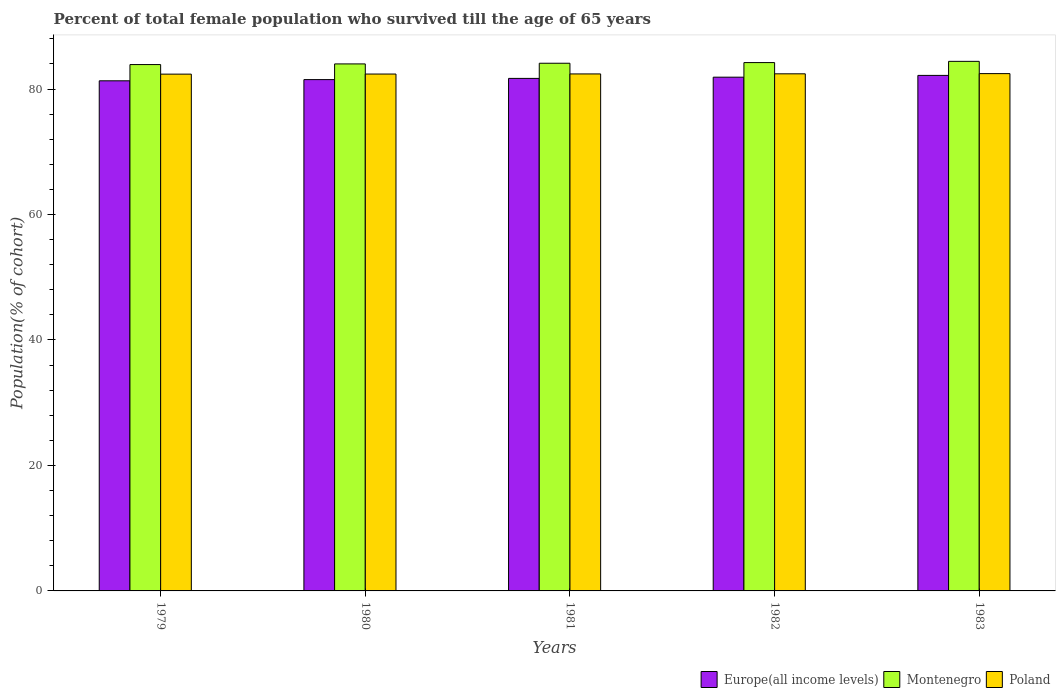How many different coloured bars are there?
Your response must be concise. 3. Are the number of bars per tick equal to the number of legend labels?
Your answer should be compact. Yes. How many bars are there on the 4th tick from the left?
Keep it short and to the point. 3. How many bars are there on the 3rd tick from the right?
Give a very brief answer. 3. What is the percentage of total female population who survived till the age of 65 years in Montenegro in 1982?
Offer a very short reply. 84.22. Across all years, what is the maximum percentage of total female population who survived till the age of 65 years in Europe(all income levels)?
Provide a short and direct response. 82.18. Across all years, what is the minimum percentage of total female population who survived till the age of 65 years in Montenegro?
Provide a succinct answer. 83.9. In which year was the percentage of total female population who survived till the age of 65 years in Europe(all income levels) maximum?
Provide a short and direct response. 1983. In which year was the percentage of total female population who survived till the age of 65 years in Europe(all income levels) minimum?
Ensure brevity in your answer.  1979. What is the total percentage of total female population who survived till the age of 65 years in Europe(all income levels) in the graph?
Give a very brief answer. 408.58. What is the difference between the percentage of total female population who survived till the age of 65 years in Europe(all income levels) in 1980 and that in 1983?
Give a very brief answer. -0.67. What is the difference between the percentage of total female population who survived till the age of 65 years in Europe(all income levels) in 1981 and the percentage of total female population who survived till the age of 65 years in Montenegro in 1979?
Your response must be concise. -2.21. What is the average percentage of total female population who survived till the age of 65 years in Europe(all income levels) per year?
Give a very brief answer. 81.72. In the year 1982, what is the difference between the percentage of total female population who survived till the age of 65 years in Montenegro and percentage of total female population who survived till the age of 65 years in Poland?
Offer a terse response. 1.79. What is the ratio of the percentage of total female population who survived till the age of 65 years in Europe(all income levels) in 1981 to that in 1982?
Offer a very short reply. 1. Is the percentage of total female population who survived till the age of 65 years in Poland in 1981 less than that in 1983?
Provide a succinct answer. Yes. What is the difference between the highest and the second highest percentage of total female population who survived till the age of 65 years in Montenegro?
Your answer should be compact. 0.2. What is the difference between the highest and the lowest percentage of total female population who survived till the age of 65 years in Europe(all income levels)?
Offer a terse response. 0.86. Is it the case that in every year, the sum of the percentage of total female population who survived till the age of 65 years in Montenegro and percentage of total female population who survived till the age of 65 years in Poland is greater than the percentage of total female population who survived till the age of 65 years in Europe(all income levels)?
Keep it short and to the point. Yes. How many bars are there?
Keep it short and to the point. 15. What is the difference between two consecutive major ticks on the Y-axis?
Ensure brevity in your answer.  20. Does the graph contain any zero values?
Offer a very short reply. No. Does the graph contain grids?
Your answer should be compact. No. How many legend labels are there?
Your answer should be compact. 3. What is the title of the graph?
Give a very brief answer. Percent of total female population who survived till the age of 65 years. Does "Poland" appear as one of the legend labels in the graph?
Offer a terse response. Yes. What is the label or title of the X-axis?
Offer a terse response. Years. What is the label or title of the Y-axis?
Provide a short and direct response. Population(% of cohort). What is the Population(% of cohort) in Europe(all income levels) in 1979?
Provide a short and direct response. 81.31. What is the Population(% of cohort) in Montenegro in 1979?
Offer a very short reply. 83.9. What is the Population(% of cohort) in Poland in 1979?
Provide a succinct answer. 82.38. What is the Population(% of cohort) of Europe(all income levels) in 1980?
Give a very brief answer. 81.5. What is the Population(% of cohort) of Montenegro in 1980?
Provide a short and direct response. 84.01. What is the Population(% of cohort) of Poland in 1980?
Your answer should be compact. 82.39. What is the Population(% of cohort) of Europe(all income levels) in 1981?
Provide a short and direct response. 81.7. What is the Population(% of cohort) in Montenegro in 1981?
Provide a succinct answer. 84.11. What is the Population(% of cohort) in Poland in 1981?
Your response must be concise. 82.41. What is the Population(% of cohort) of Europe(all income levels) in 1982?
Give a very brief answer. 81.89. What is the Population(% of cohort) in Montenegro in 1982?
Ensure brevity in your answer.  84.22. What is the Population(% of cohort) of Poland in 1982?
Give a very brief answer. 82.43. What is the Population(% of cohort) in Europe(all income levels) in 1983?
Make the answer very short. 82.18. What is the Population(% of cohort) of Montenegro in 1983?
Offer a terse response. 84.41. What is the Population(% of cohort) in Poland in 1983?
Make the answer very short. 82.46. Across all years, what is the maximum Population(% of cohort) in Europe(all income levels)?
Your answer should be very brief. 82.18. Across all years, what is the maximum Population(% of cohort) of Montenegro?
Your answer should be very brief. 84.41. Across all years, what is the maximum Population(% of cohort) of Poland?
Offer a very short reply. 82.46. Across all years, what is the minimum Population(% of cohort) in Europe(all income levels)?
Provide a short and direct response. 81.31. Across all years, what is the minimum Population(% of cohort) in Montenegro?
Your answer should be compact. 83.9. Across all years, what is the minimum Population(% of cohort) of Poland?
Your response must be concise. 82.38. What is the total Population(% of cohort) in Europe(all income levels) in the graph?
Offer a very short reply. 408.58. What is the total Population(% of cohort) in Montenegro in the graph?
Keep it short and to the point. 420.65. What is the total Population(% of cohort) in Poland in the graph?
Provide a short and direct response. 412.07. What is the difference between the Population(% of cohort) in Europe(all income levels) in 1979 and that in 1980?
Your answer should be compact. -0.19. What is the difference between the Population(% of cohort) of Montenegro in 1979 and that in 1980?
Ensure brevity in your answer.  -0.1. What is the difference between the Population(% of cohort) in Poland in 1979 and that in 1980?
Ensure brevity in your answer.  -0.02. What is the difference between the Population(% of cohort) in Europe(all income levels) in 1979 and that in 1981?
Your answer should be very brief. -0.38. What is the difference between the Population(% of cohort) in Montenegro in 1979 and that in 1981?
Make the answer very short. -0.21. What is the difference between the Population(% of cohort) of Poland in 1979 and that in 1981?
Offer a terse response. -0.03. What is the difference between the Population(% of cohort) of Europe(all income levels) in 1979 and that in 1982?
Your response must be concise. -0.58. What is the difference between the Population(% of cohort) of Montenegro in 1979 and that in 1982?
Provide a succinct answer. -0.31. What is the difference between the Population(% of cohort) of Poland in 1979 and that in 1982?
Keep it short and to the point. -0.05. What is the difference between the Population(% of cohort) of Europe(all income levels) in 1979 and that in 1983?
Your answer should be compact. -0.86. What is the difference between the Population(% of cohort) of Montenegro in 1979 and that in 1983?
Offer a terse response. -0.51. What is the difference between the Population(% of cohort) in Poland in 1979 and that in 1983?
Offer a terse response. -0.08. What is the difference between the Population(% of cohort) in Europe(all income levels) in 1980 and that in 1981?
Ensure brevity in your answer.  -0.19. What is the difference between the Population(% of cohort) of Montenegro in 1980 and that in 1981?
Offer a terse response. -0.1. What is the difference between the Population(% of cohort) of Poland in 1980 and that in 1981?
Make the answer very short. -0.02. What is the difference between the Population(% of cohort) of Europe(all income levels) in 1980 and that in 1982?
Give a very brief answer. -0.39. What is the difference between the Population(% of cohort) of Montenegro in 1980 and that in 1982?
Offer a terse response. -0.21. What is the difference between the Population(% of cohort) in Poland in 1980 and that in 1982?
Offer a terse response. -0.03. What is the difference between the Population(% of cohort) of Europe(all income levels) in 1980 and that in 1983?
Provide a short and direct response. -0.67. What is the difference between the Population(% of cohort) in Montenegro in 1980 and that in 1983?
Keep it short and to the point. -0.41. What is the difference between the Population(% of cohort) of Poland in 1980 and that in 1983?
Your response must be concise. -0.07. What is the difference between the Population(% of cohort) in Europe(all income levels) in 1981 and that in 1982?
Make the answer very short. -0.2. What is the difference between the Population(% of cohort) in Montenegro in 1981 and that in 1982?
Offer a terse response. -0.1. What is the difference between the Population(% of cohort) in Poland in 1981 and that in 1982?
Your response must be concise. -0.02. What is the difference between the Population(% of cohort) of Europe(all income levels) in 1981 and that in 1983?
Your response must be concise. -0.48. What is the difference between the Population(% of cohort) of Montenegro in 1981 and that in 1983?
Offer a terse response. -0.3. What is the difference between the Population(% of cohort) in Poland in 1981 and that in 1983?
Provide a succinct answer. -0.05. What is the difference between the Population(% of cohort) of Europe(all income levels) in 1982 and that in 1983?
Your answer should be compact. -0.28. What is the difference between the Population(% of cohort) of Montenegro in 1982 and that in 1983?
Give a very brief answer. -0.2. What is the difference between the Population(% of cohort) in Poland in 1982 and that in 1983?
Make the answer very short. -0.03. What is the difference between the Population(% of cohort) of Europe(all income levels) in 1979 and the Population(% of cohort) of Montenegro in 1980?
Keep it short and to the point. -2.69. What is the difference between the Population(% of cohort) in Europe(all income levels) in 1979 and the Population(% of cohort) in Poland in 1980?
Offer a terse response. -1.08. What is the difference between the Population(% of cohort) of Montenegro in 1979 and the Population(% of cohort) of Poland in 1980?
Your response must be concise. 1.51. What is the difference between the Population(% of cohort) in Europe(all income levels) in 1979 and the Population(% of cohort) in Montenegro in 1981?
Provide a short and direct response. -2.8. What is the difference between the Population(% of cohort) in Europe(all income levels) in 1979 and the Population(% of cohort) in Poland in 1981?
Keep it short and to the point. -1.1. What is the difference between the Population(% of cohort) in Montenegro in 1979 and the Population(% of cohort) in Poland in 1981?
Offer a very short reply. 1.49. What is the difference between the Population(% of cohort) of Europe(all income levels) in 1979 and the Population(% of cohort) of Montenegro in 1982?
Provide a short and direct response. -2.9. What is the difference between the Population(% of cohort) in Europe(all income levels) in 1979 and the Population(% of cohort) in Poland in 1982?
Give a very brief answer. -1.11. What is the difference between the Population(% of cohort) of Montenegro in 1979 and the Population(% of cohort) of Poland in 1982?
Offer a very short reply. 1.48. What is the difference between the Population(% of cohort) in Europe(all income levels) in 1979 and the Population(% of cohort) in Montenegro in 1983?
Offer a very short reply. -3.1. What is the difference between the Population(% of cohort) of Europe(all income levels) in 1979 and the Population(% of cohort) of Poland in 1983?
Offer a very short reply. -1.14. What is the difference between the Population(% of cohort) of Montenegro in 1979 and the Population(% of cohort) of Poland in 1983?
Your response must be concise. 1.44. What is the difference between the Population(% of cohort) in Europe(all income levels) in 1980 and the Population(% of cohort) in Montenegro in 1981?
Ensure brevity in your answer.  -2.61. What is the difference between the Population(% of cohort) in Europe(all income levels) in 1980 and the Population(% of cohort) in Poland in 1981?
Your answer should be compact. -0.91. What is the difference between the Population(% of cohort) in Montenegro in 1980 and the Population(% of cohort) in Poland in 1981?
Offer a terse response. 1.6. What is the difference between the Population(% of cohort) in Europe(all income levels) in 1980 and the Population(% of cohort) in Montenegro in 1982?
Ensure brevity in your answer.  -2.71. What is the difference between the Population(% of cohort) of Europe(all income levels) in 1980 and the Population(% of cohort) of Poland in 1982?
Make the answer very short. -0.92. What is the difference between the Population(% of cohort) in Montenegro in 1980 and the Population(% of cohort) in Poland in 1982?
Provide a short and direct response. 1.58. What is the difference between the Population(% of cohort) of Europe(all income levels) in 1980 and the Population(% of cohort) of Montenegro in 1983?
Offer a very short reply. -2.91. What is the difference between the Population(% of cohort) of Europe(all income levels) in 1980 and the Population(% of cohort) of Poland in 1983?
Offer a very short reply. -0.95. What is the difference between the Population(% of cohort) of Montenegro in 1980 and the Population(% of cohort) of Poland in 1983?
Ensure brevity in your answer.  1.55. What is the difference between the Population(% of cohort) of Europe(all income levels) in 1981 and the Population(% of cohort) of Montenegro in 1982?
Your answer should be compact. -2.52. What is the difference between the Population(% of cohort) of Europe(all income levels) in 1981 and the Population(% of cohort) of Poland in 1982?
Offer a terse response. -0.73. What is the difference between the Population(% of cohort) in Montenegro in 1981 and the Population(% of cohort) in Poland in 1982?
Offer a terse response. 1.69. What is the difference between the Population(% of cohort) in Europe(all income levels) in 1981 and the Population(% of cohort) in Montenegro in 1983?
Offer a terse response. -2.72. What is the difference between the Population(% of cohort) of Europe(all income levels) in 1981 and the Population(% of cohort) of Poland in 1983?
Your answer should be compact. -0.76. What is the difference between the Population(% of cohort) in Montenegro in 1981 and the Population(% of cohort) in Poland in 1983?
Offer a terse response. 1.65. What is the difference between the Population(% of cohort) of Europe(all income levels) in 1982 and the Population(% of cohort) of Montenegro in 1983?
Make the answer very short. -2.52. What is the difference between the Population(% of cohort) of Europe(all income levels) in 1982 and the Population(% of cohort) of Poland in 1983?
Give a very brief answer. -0.57. What is the difference between the Population(% of cohort) in Montenegro in 1982 and the Population(% of cohort) in Poland in 1983?
Make the answer very short. 1.76. What is the average Population(% of cohort) of Europe(all income levels) per year?
Provide a short and direct response. 81.72. What is the average Population(% of cohort) in Montenegro per year?
Provide a succinct answer. 84.13. What is the average Population(% of cohort) in Poland per year?
Your response must be concise. 82.41. In the year 1979, what is the difference between the Population(% of cohort) in Europe(all income levels) and Population(% of cohort) in Montenegro?
Ensure brevity in your answer.  -2.59. In the year 1979, what is the difference between the Population(% of cohort) in Europe(all income levels) and Population(% of cohort) in Poland?
Offer a very short reply. -1.06. In the year 1979, what is the difference between the Population(% of cohort) in Montenegro and Population(% of cohort) in Poland?
Your answer should be very brief. 1.53. In the year 1980, what is the difference between the Population(% of cohort) of Europe(all income levels) and Population(% of cohort) of Montenegro?
Provide a short and direct response. -2.5. In the year 1980, what is the difference between the Population(% of cohort) of Europe(all income levels) and Population(% of cohort) of Poland?
Ensure brevity in your answer.  -0.89. In the year 1980, what is the difference between the Population(% of cohort) of Montenegro and Population(% of cohort) of Poland?
Your answer should be compact. 1.61. In the year 1981, what is the difference between the Population(% of cohort) in Europe(all income levels) and Population(% of cohort) in Montenegro?
Your response must be concise. -2.42. In the year 1981, what is the difference between the Population(% of cohort) in Europe(all income levels) and Population(% of cohort) in Poland?
Your answer should be very brief. -0.71. In the year 1981, what is the difference between the Population(% of cohort) in Montenegro and Population(% of cohort) in Poland?
Give a very brief answer. 1.7. In the year 1982, what is the difference between the Population(% of cohort) in Europe(all income levels) and Population(% of cohort) in Montenegro?
Offer a terse response. -2.32. In the year 1982, what is the difference between the Population(% of cohort) of Europe(all income levels) and Population(% of cohort) of Poland?
Keep it short and to the point. -0.53. In the year 1982, what is the difference between the Population(% of cohort) of Montenegro and Population(% of cohort) of Poland?
Provide a short and direct response. 1.79. In the year 1983, what is the difference between the Population(% of cohort) in Europe(all income levels) and Population(% of cohort) in Montenegro?
Provide a short and direct response. -2.24. In the year 1983, what is the difference between the Population(% of cohort) in Europe(all income levels) and Population(% of cohort) in Poland?
Your response must be concise. -0.28. In the year 1983, what is the difference between the Population(% of cohort) of Montenegro and Population(% of cohort) of Poland?
Offer a very short reply. 1.96. What is the ratio of the Population(% of cohort) of Poland in 1979 to that in 1980?
Keep it short and to the point. 1. What is the ratio of the Population(% of cohort) of Montenegro in 1979 to that in 1982?
Ensure brevity in your answer.  1. What is the ratio of the Population(% of cohort) in Poland in 1979 to that in 1982?
Offer a terse response. 1. What is the ratio of the Population(% of cohort) in Montenegro in 1979 to that in 1983?
Make the answer very short. 0.99. What is the ratio of the Population(% of cohort) of Europe(all income levels) in 1980 to that in 1981?
Keep it short and to the point. 1. What is the ratio of the Population(% of cohort) of Montenegro in 1980 to that in 1981?
Keep it short and to the point. 1. What is the ratio of the Population(% of cohort) in Europe(all income levels) in 1980 to that in 1982?
Offer a very short reply. 1. What is the ratio of the Population(% of cohort) of Montenegro in 1980 to that in 1982?
Provide a succinct answer. 1. What is the ratio of the Population(% of cohort) in Poland in 1980 to that in 1983?
Ensure brevity in your answer.  1. What is the ratio of the Population(% of cohort) in Europe(all income levels) in 1981 to that in 1982?
Provide a short and direct response. 1. What is the ratio of the Population(% of cohort) of Europe(all income levels) in 1981 to that in 1983?
Your answer should be very brief. 0.99. What is the ratio of the Population(% of cohort) of Poland in 1981 to that in 1983?
Provide a short and direct response. 1. What is the ratio of the Population(% of cohort) in Europe(all income levels) in 1982 to that in 1983?
Provide a short and direct response. 1. What is the difference between the highest and the second highest Population(% of cohort) of Europe(all income levels)?
Provide a succinct answer. 0.28. What is the difference between the highest and the second highest Population(% of cohort) in Montenegro?
Ensure brevity in your answer.  0.2. What is the difference between the highest and the second highest Population(% of cohort) in Poland?
Your answer should be compact. 0.03. What is the difference between the highest and the lowest Population(% of cohort) in Europe(all income levels)?
Make the answer very short. 0.86. What is the difference between the highest and the lowest Population(% of cohort) in Montenegro?
Your response must be concise. 0.51. What is the difference between the highest and the lowest Population(% of cohort) in Poland?
Provide a short and direct response. 0.08. 